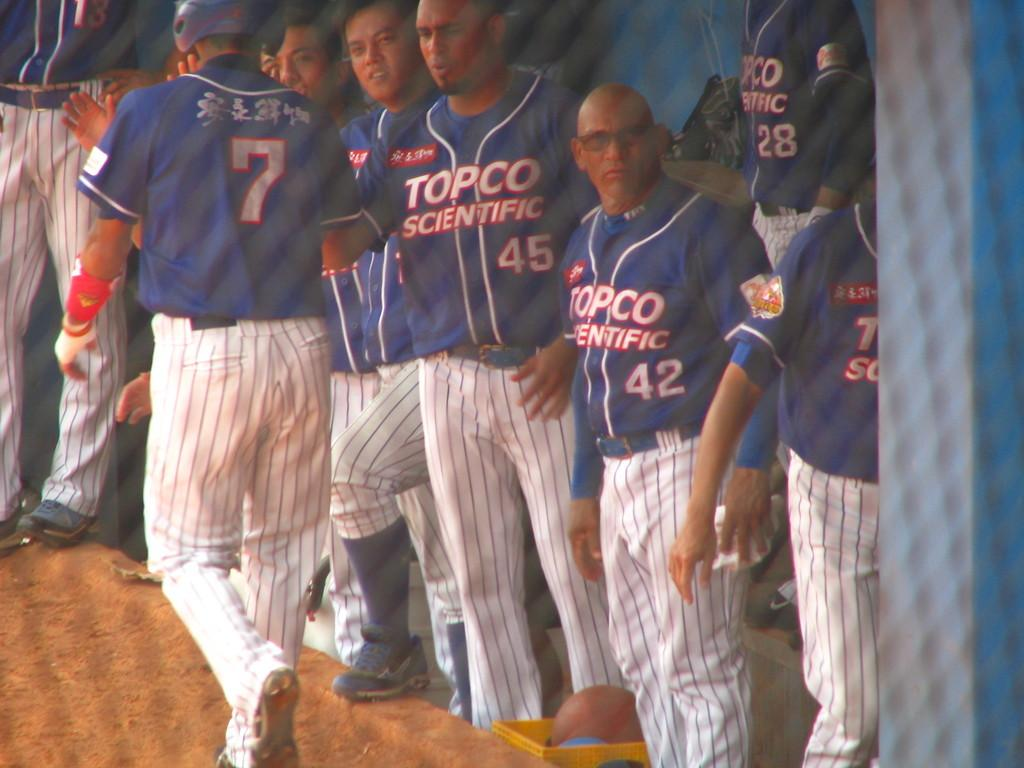<image>
Share a concise interpretation of the image provided. A group of baseball player in TOPCO SCIENTIFIC uniform. 